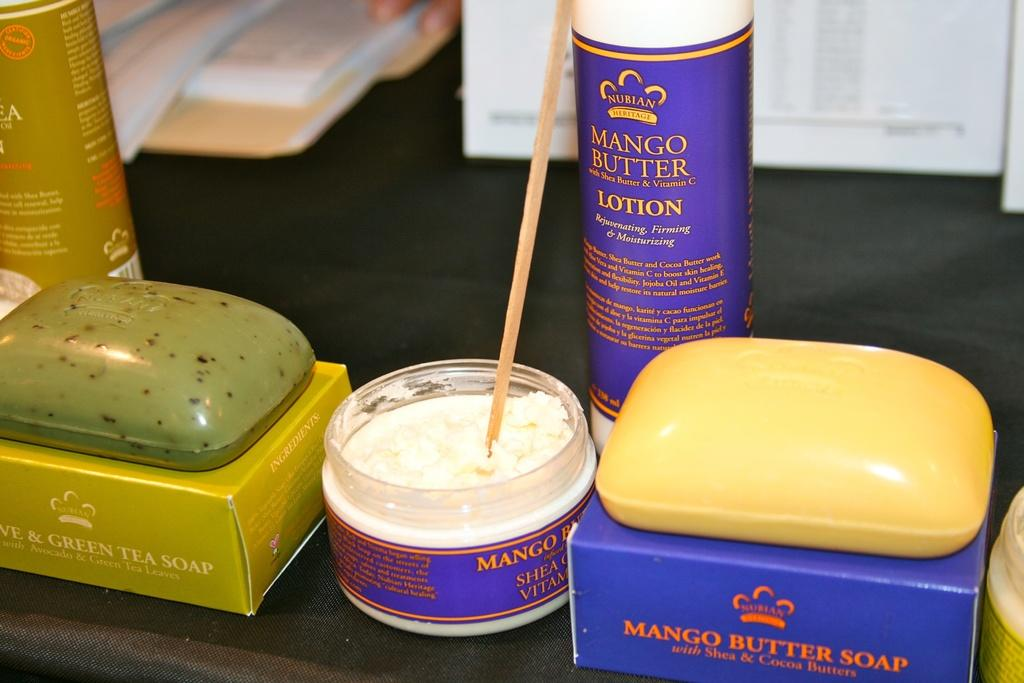<image>
Write a terse but informative summary of the picture. Display of white cream made by Mango Butter Soap 